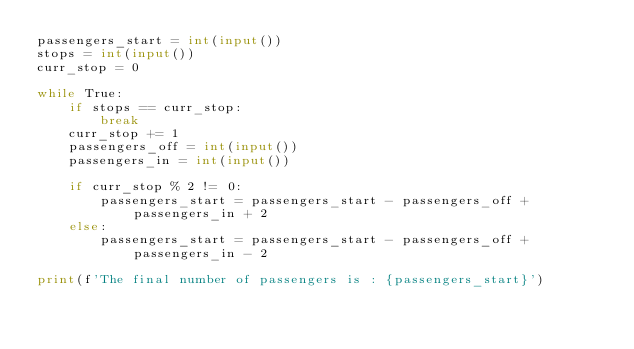Convert code to text. <code><loc_0><loc_0><loc_500><loc_500><_Python_>passengers_start = int(input())
stops = int(input())
curr_stop = 0

while True:
    if stops == curr_stop:
        break
    curr_stop += 1
    passengers_off = int(input())
    passengers_in = int(input())

    if curr_stop % 2 != 0:
        passengers_start = passengers_start - passengers_off + passengers_in + 2
    else:
        passengers_start = passengers_start - passengers_off + passengers_in - 2

print(f'The final number of passengers is : {passengers_start}')
</code> 